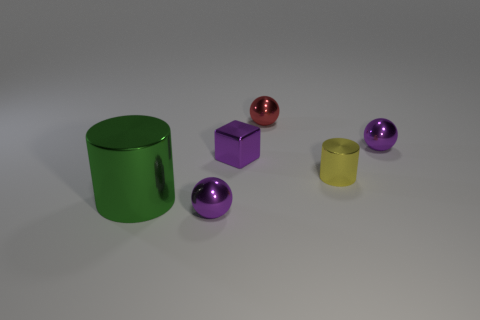How many purple spheres must be subtracted to get 1 purple spheres? 1 Add 2 metal blocks. How many objects exist? 8 Subtract all blocks. How many objects are left? 5 Add 2 big green shiny objects. How many big green shiny objects are left? 3 Add 6 purple metal spheres. How many purple metal spheres exist? 8 Subtract 0 brown spheres. How many objects are left? 6 Subtract all purple metal things. Subtract all small yellow metal things. How many objects are left? 2 